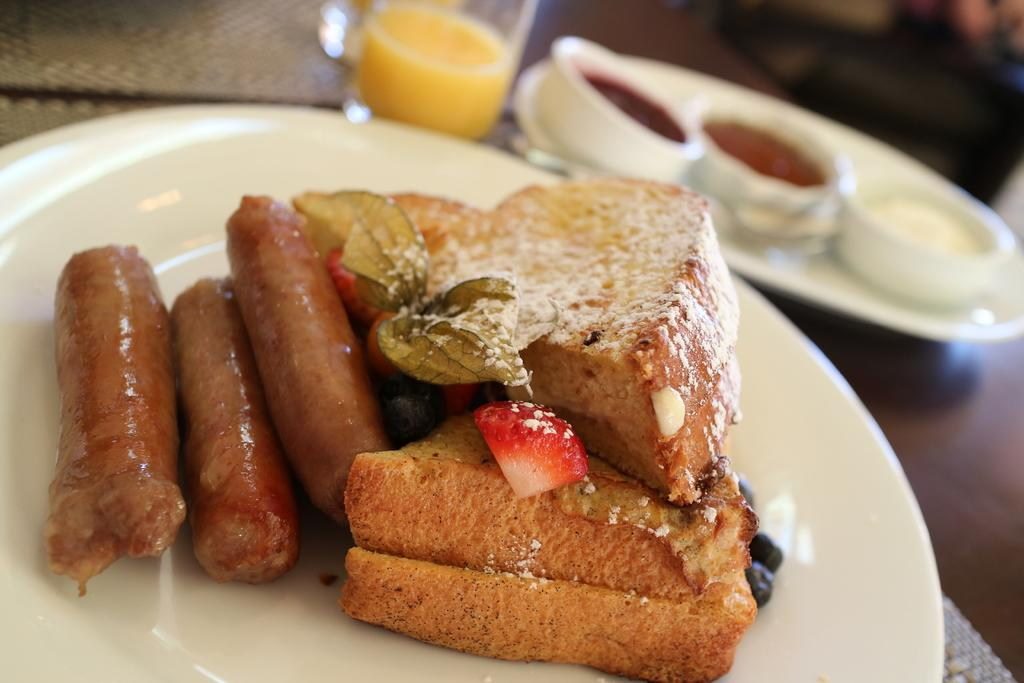What is on the plate that is visible in the image? There is a plate with food in the image. What else can be seen in the image besides the plate with food? There is another plate in the top right of the image containing bowls, and there is a glass at the top of the image. How does the feeling of the pump affect the food in the image? There is no mention of a feeling or a pump in the image, so this question cannot be answered. 